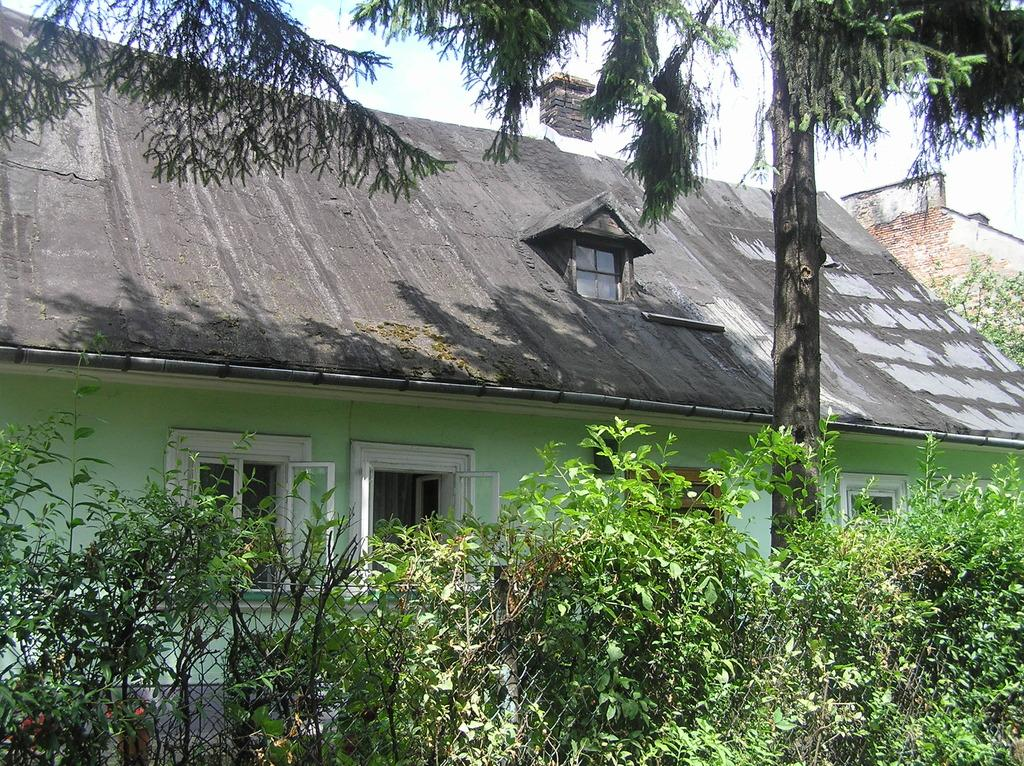What is the main subject of the image? The main subject of the image is a house. What can be seen in front of the house? There are plants and trees in front of the house. What is visible in the background of the image? The sky is visible in the background of the image. How many bean plants are growing in front of the house in the image? There is no mention of bean plants in the image; only plants and trees are mentioned. What type of pizzas are being served at the house in the image? There is no indication of pizzas or any food in the image; it only features a house, plants, trees, and the sky. 